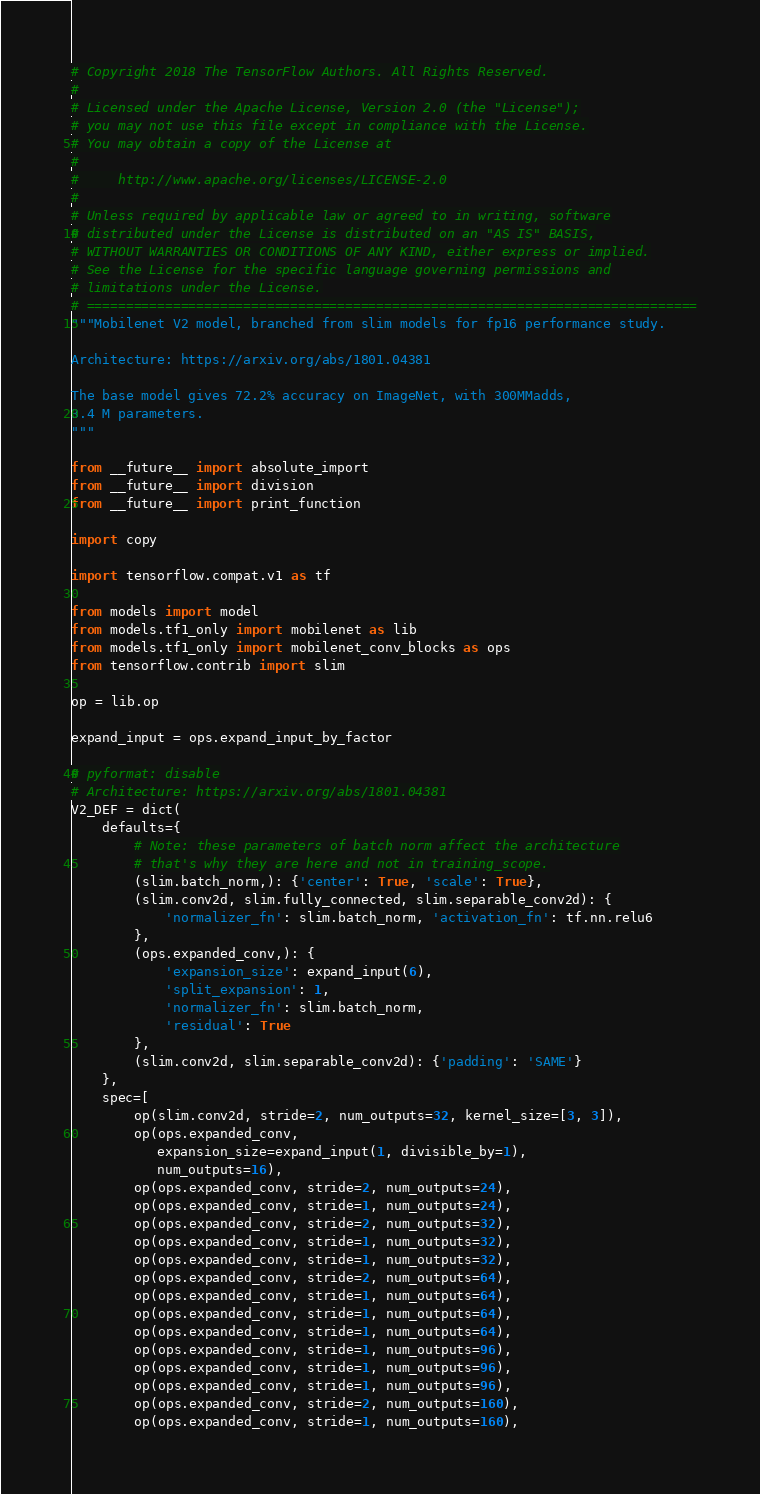<code> <loc_0><loc_0><loc_500><loc_500><_Python_># Copyright 2018 The TensorFlow Authors. All Rights Reserved.
#
# Licensed under the Apache License, Version 2.0 (the "License");
# you may not use this file except in compliance with the License.
# You may obtain a copy of the License at
#
#     http://www.apache.org/licenses/LICENSE-2.0
#
# Unless required by applicable law or agreed to in writing, software
# distributed under the License is distributed on an "AS IS" BASIS,
# WITHOUT WARRANTIES OR CONDITIONS OF ANY KIND, either express or implied.
# See the License for the specific language governing permissions and
# limitations under the License.
# ==============================================================================
"""Mobilenet V2 model, branched from slim models for fp16 performance study.

Architecture: https://arxiv.org/abs/1801.04381

The base model gives 72.2% accuracy on ImageNet, with 300MMadds,
3.4 M parameters.
"""

from __future__ import absolute_import
from __future__ import division
from __future__ import print_function

import copy

import tensorflow.compat.v1 as tf

from models import model
from models.tf1_only import mobilenet as lib
from models.tf1_only import mobilenet_conv_blocks as ops
from tensorflow.contrib import slim

op = lib.op

expand_input = ops.expand_input_by_factor

# pyformat: disable
# Architecture: https://arxiv.org/abs/1801.04381
V2_DEF = dict(
    defaults={
        # Note: these parameters of batch norm affect the architecture
        # that's why they are here and not in training_scope.
        (slim.batch_norm,): {'center': True, 'scale': True},
        (slim.conv2d, slim.fully_connected, slim.separable_conv2d): {
            'normalizer_fn': slim.batch_norm, 'activation_fn': tf.nn.relu6
        },
        (ops.expanded_conv,): {
            'expansion_size': expand_input(6),
            'split_expansion': 1,
            'normalizer_fn': slim.batch_norm,
            'residual': True
        },
        (slim.conv2d, slim.separable_conv2d): {'padding': 'SAME'}
    },
    spec=[
        op(slim.conv2d, stride=2, num_outputs=32, kernel_size=[3, 3]),
        op(ops.expanded_conv,
           expansion_size=expand_input(1, divisible_by=1),
           num_outputs=16),
        op(ops.expanded_conv, stride=2, num_outputs=24),
        op(ops.expanded_conv, stride=1, num_outputs=24),
        op(ops.expanded_conv, stride=2, num_outputs=32),
        op(ops.expanded_conv, stride=1, num_outputs=32),
        op(ops.expanded_conv, stride=1, num_outputs=32),
        op(ops.expanded_conv, stride=2, num_outputs=64),
        op(ops.expanded_conv, stride=1, num_outputs=64),
        op(ops.expanded_conv, stride=1, num_outputs=64),
        op(ops.expanded_conv, stride=1, num_outputs=64),
        op(ops.expanded_conv, stride=1, num_outputs=96),
        op(ops.expanded_conv, stride=1, num_outputs=96),
        op(ops.expanded_conv, stride=1, num_outputs=96),
        op(ops.expanded_conv, stride=2, num_outputs=160),
        op(ops.expanded_conv, stride=1, num_outputs=160),</code> 